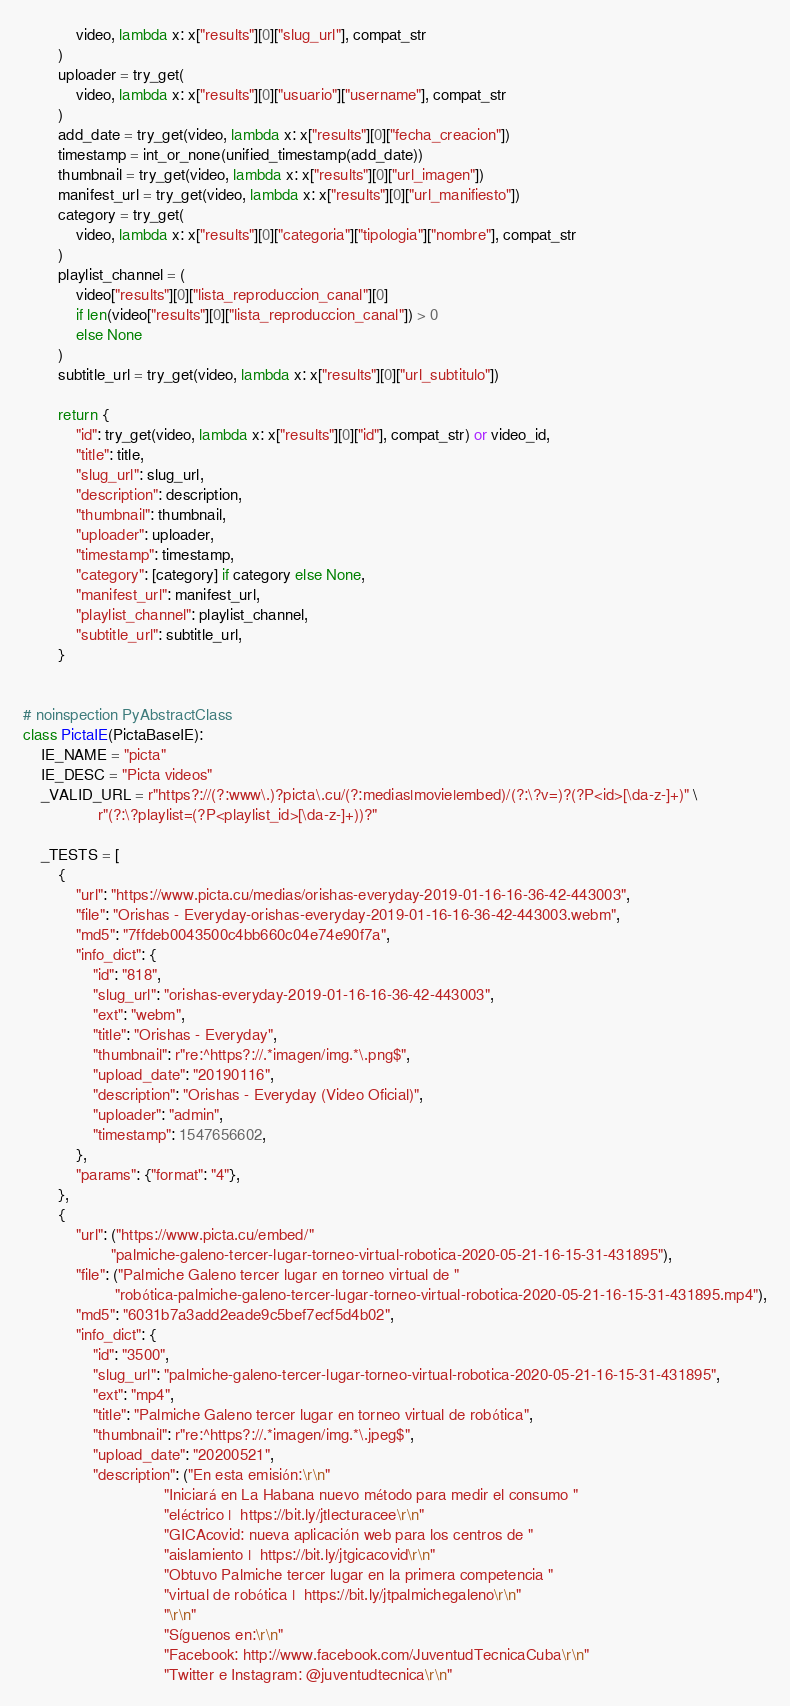Convert code to text. <code><loc_0><loc_0><loc_500><loc_500><_Python_>            video, lambda x: x["results"][0]["slug_url"], compat_str
        )
        uploader = try_get(
            video, lambda x: x["results"][0]["usuario"]["username"], compat_str
        )
        add_date = try_get(video, lambda x: x["results"][0]["fecha_creacion"])
        timestamp = int_or_none(unified_timestamp(add_date))
        thumbnail = try_get(video, lambda x: x["results"][0]["url_imagen"])
        manifest_url = try_get(video, lambda x: x["results"][0]["url_manifiesto"])
        category = try_get(
            video, lambda x: x["results"][0]["categoria"]["tipologia"]["nombre"], compat_str
        )
        playlist_channel = (
            video["results"][0]["lista_reproduccion_canal"][0]
            if len(video["results"][0]["lista_reproduccion_canal"]) > 0
            else None
        )
        subtitle_url = try_get(video, lambda x: x["results"][0]["url_subtitulo"])

        return {
            "id": try_get(video, lambda x: x["results"][0]["id"], compat_str) or video_id,
            "title": title,
            "slug_url": slug_url,
            "description": description,
            "thumbnail": thumbnail,
            "uploader": uploader,
            "timestamp": timestamp,
            "category": [category] if category else None,
            "manifest_url": manifest_url,
            "playlist_channel": playlist_channel,
            "subtitle_url": subtitle_url,
        }


# noinspection PyAbstractClass
class PictaIE(PictaBaseIE):
    IE_NAME = "picta"
    IE_DESC = "Picta videos"
    _VALID_URL = r"https?://(?:www\.)?picta\.cu/(?:medias|movie|embed)/(?:\?v=)?(?P<id>[\da-z-]+)" \
                 r"(?:\?playlist=(?P<playlist_id>[\da-z-]+))?"

    _TESTS = [
        {
            "url": "https://www.picta.cu/medias/orishas-everyday-2019-01-16-16-36-42-443003",
            "file": "Orishas - Everyday-orishas-everyday-2019-01-16-16-36-42-443003.webm",
            "md5": "7ffdeb0043500c4bb660c04e74e90f7a",
            "info_dict": {
                "id": "818",
                "slug_url": "orishas-everyday-2019-01-16-16-36-42-443003",
                "ext": "webm",
                "title": "Orishas - Everyday",
                "thumbnail": r"re:^https?://.*imagen/img.*\.png$",
                "upload_date": "20190116",
                "description": "Orishas - Everyday (Video Oficial)",
                "uploader": "admin",
                "timestamp": 1547656602,
            },
            "params": {"format": "4"},
        },
        {
            "url": ("https://www.picta.cu/embed/"
                    "palmiche-galeno-tercer-lugar-torneo-virtual-robotica-2020-05-21-16-15-31-431895"),
            "file": ("Palmiche Galeno tercer lugar en torneo virtual de "
                     "robótica-palmiche-galeno-tercer-lugar-torneo-virtual-robotica-2020-05-21-16-15-31-431895.mp4"),
            "md5": "6031b7a3add2eade9c5bef7ecf5d4b02",
            "info_dict": {
                "id": "3500",
                "slug_url": "palmiche-galeno-tercer-lugar-torneo-virtual-robotica-2020-05-21-16-15-31-431895",
                "ext": "mp4",
                "title": "Palmiche Galeno tercer lugar en torneo virtual de robótica",
                "thumbnail": r"re:^https?://.*imagen/img.*\.jpeg$",
                "upload_date": "20200521",
                "description": ("En esta emisión:\r\n"
                                "Iniciará en La Habana nuevo método para medir el consumo "
                                "eléctrico |  https://bit.ly/jtlecturacee\r\n"
                                "GICAcovid: nueva aplicación web para los centros de "
                                "aislamiento |  https://bit.ly/jtgicacovid\r\n"
                                "Obtuvo Palmiche tercer lugar en la primera competencia "
                                "virtual de robótica |  https://bit.ly/jtpalmichegaleno\r\n"
                                "\r\n"
                                "Síguenos en:\r\n"
                                "Facebook: http://www.facebook.com/JuventudTecnicaCuba\r\n"
                                "Twitter e Instagram: @juventudtecnica\r\n"</code> 